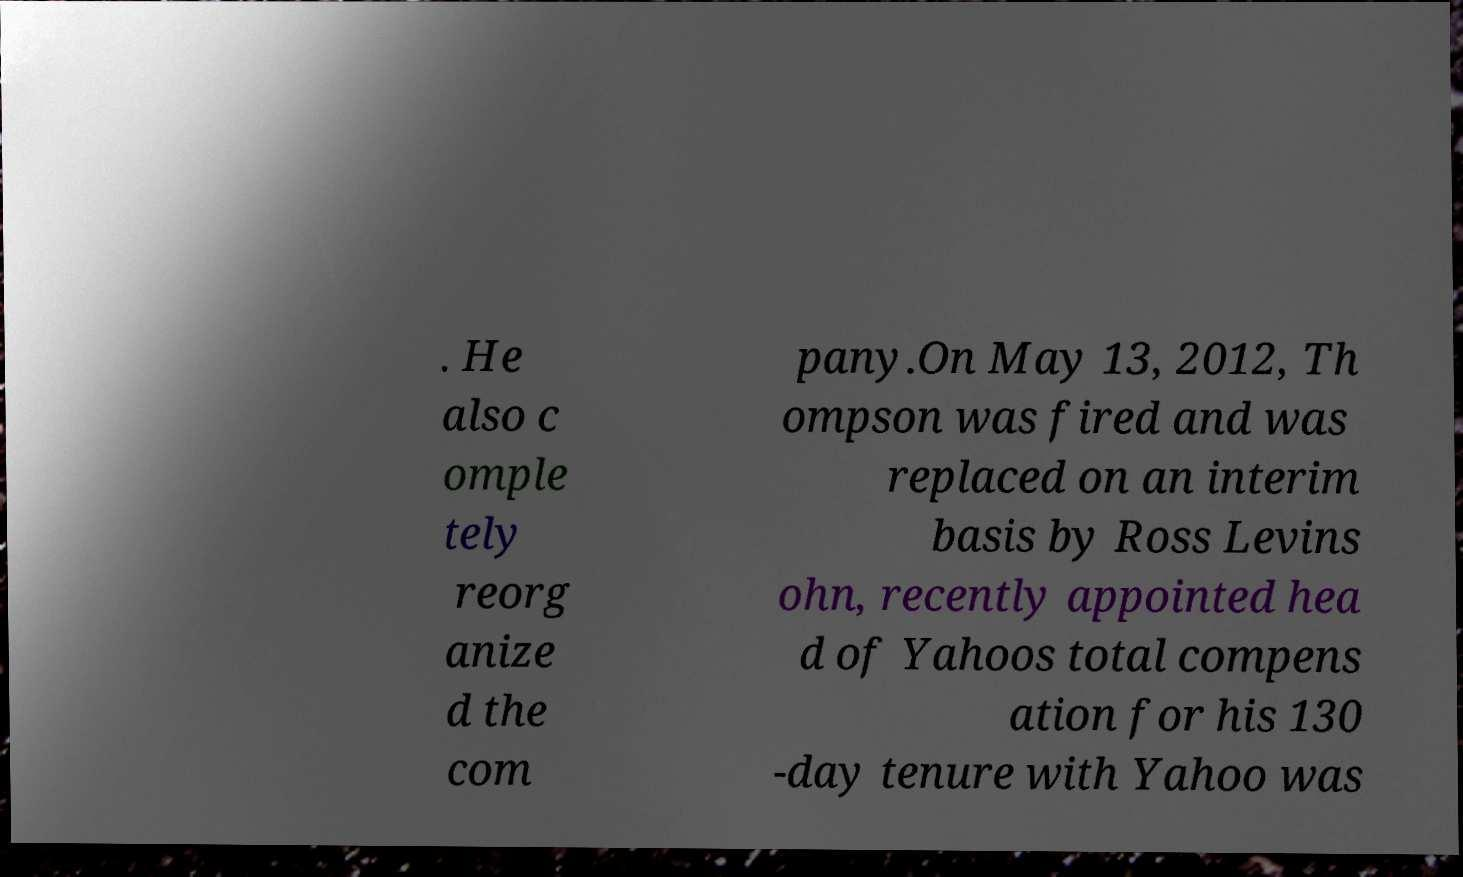I need the written content from this picture converted into text. Can you do that? . He also c omple tely reorg anize d the com pany.On May 13, 2012, Th ompson was fired and was replaced on an interim basis by Ross Levins ohn, recently appointed hea d of Yahoos total compens ation for his 130 -day tenure with Yahoo was 